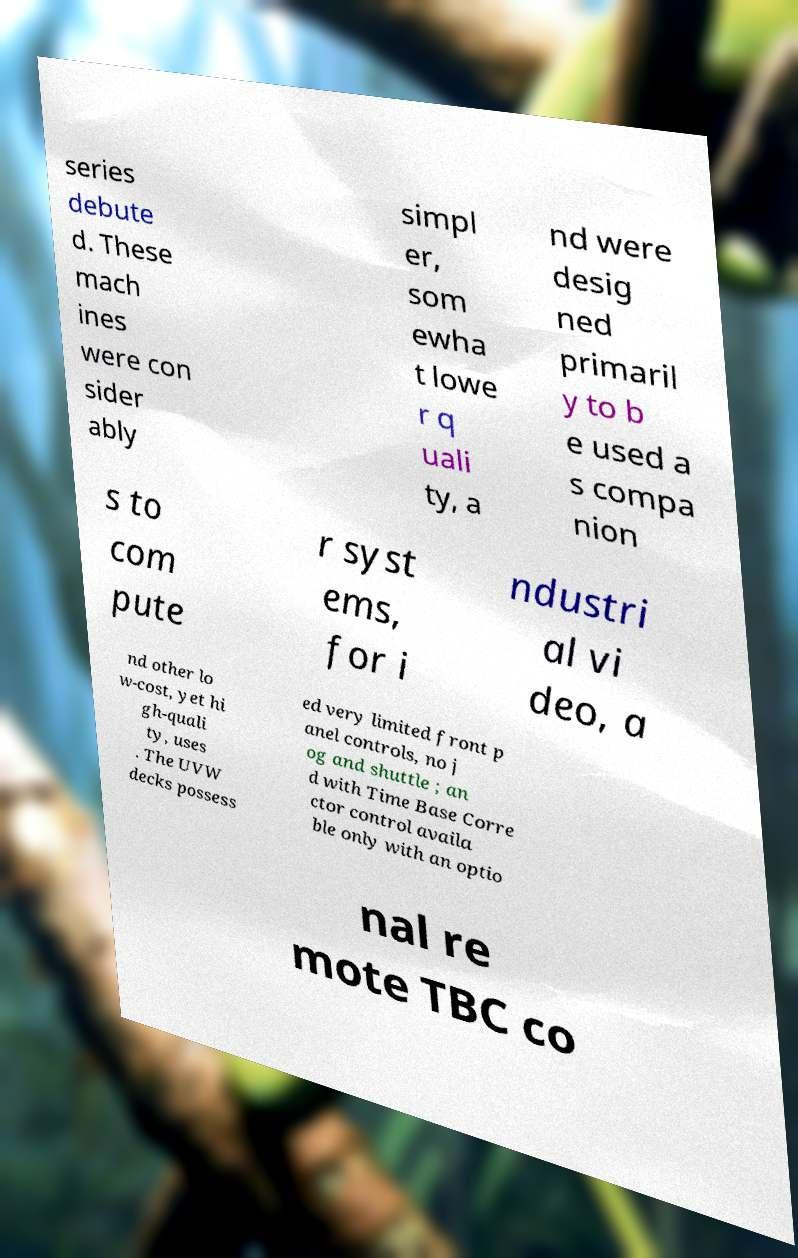I need the written content from this picture converted into text. Can you do that? series debute d. These mach ines were con sider ably simpl er, som ewha t lowe r q uali ty, a nd were desig ned primaril y to b e used a s compa nion s to com pute r syst ems, for i ndustri al vi deo, a nd other lo w-cost, yet hi gh-quali ty, uses . The UVW decks possess ed very limited front p anel controls, no j og and shuttle ; an d with Time Base Corre ctor control availa ble only with an optio nal re mote TBC co 